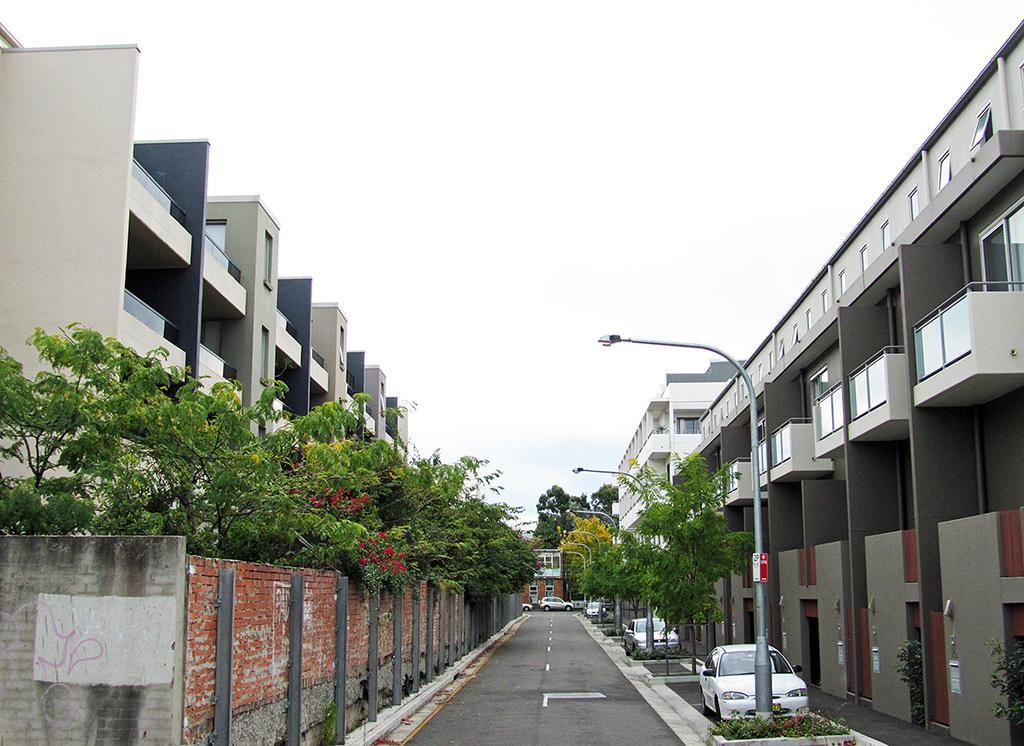Describe this image in one or two sentences. In this picture we can see the buildings, windows, balconies, poles, lights, trees, cars, road, wall. At the top of the image we can see the sky. At the bottom of the image we can see the plants and road. 